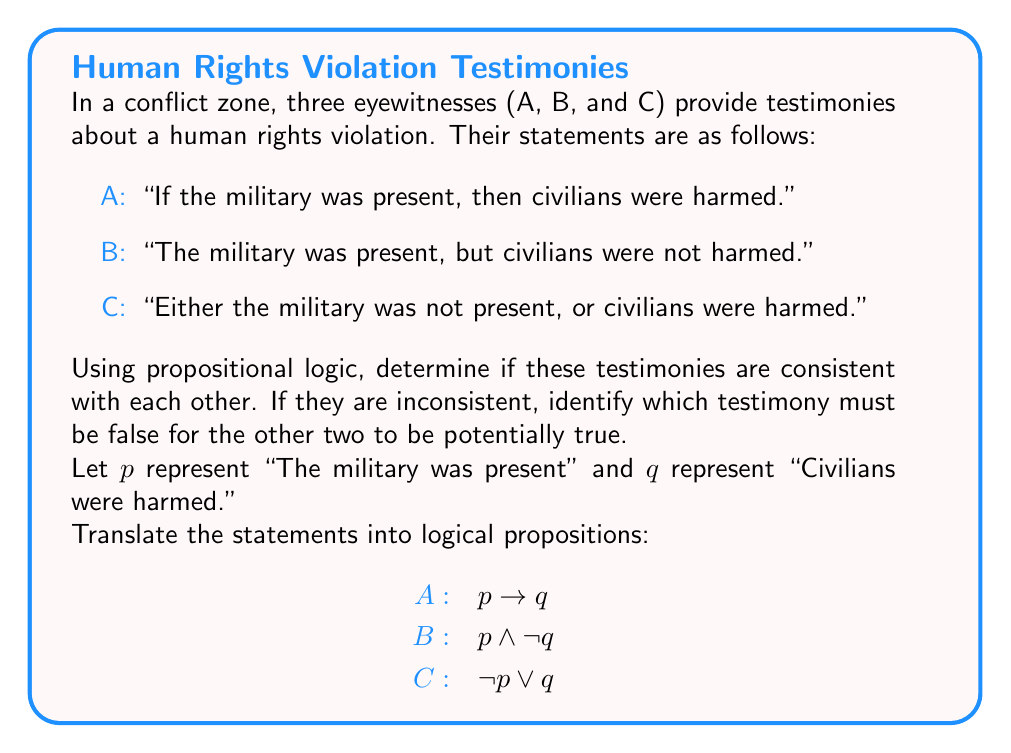Help me with this question. Let's evaluate the consistency of these testimonies using propositional logic:

1) First, we'll construct a truth table for all propositions:

   $p$ | $q$ | $p \rightarrow q$ | $p \wedge \neg q$ | $\neg p \vee q$
   ----+-----+-----------------+------------------+--------------
   T   | T   |       T         |        F         |      T
   T   | F   |       F         |        T         |      F
   F   | T   |       T         |        F         |      T
   F   | F   |       T         |        F         |      T

2) For the testimonies to be consistent, there must be at least one row where all statements are true simultaneously.

3) Examining the truth table, we see that there is no row where all three propositions are true simultaneously.

4) This means the testimonies are inconsistent with each other.

5) To determine which testimony must be false for the other two to be potentially true, we'll check each combination:

   - If A and B are true: This is impossible as they contradict each other directly.
   - If A and C are true: This is possible when $p$ is true and $q$ is true (first row of the truth table).
   - If B and C are true: This is impossible as they also contradict each other.

6) Therefore, testimony B ($ p \wedge \neg q $) must be false for A and C to be potentially true.

This analysis demonstrates how propositional logic can be used to evaluate conflicting eyewitness testimonies in human rights investigations, helping to identify inconsistencies and potential false statements.
Answer: Testimonies are inconsistent. B must be false for A and C to be potentially true. 